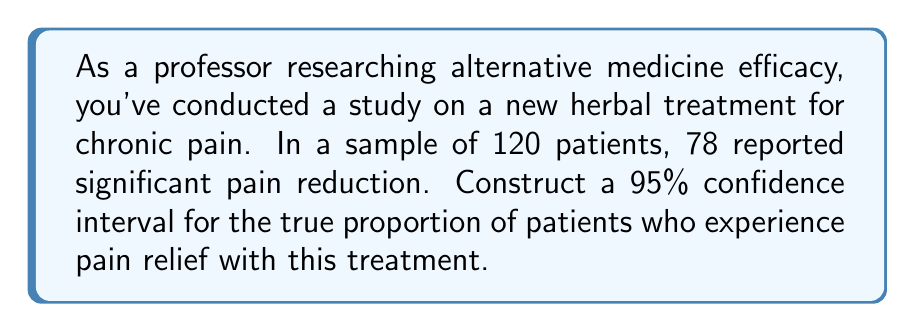Can you answer this question? Let's approach this step-by-step:

1) We're dealing with a proportion, so we'll use the formula for a confidence interval for a population proportion:

   $$\hat{p} \pm z^* \sqrt{\frac{\hat{p}(1-\hat{p})}{n}}$$

   Where:
   $\hat{p}$ = sample proportion
   $z^*$ = critical value for desired confidence level
   $n$ = sample size

2) Calculate $\hat{p}$:
   $$\hat{p} = \frac{78}{120} = 0.65$$

3) For a 95% confidence interval, $z^* = 1.96$

4) Now, let's plug these values into our formula:

   $$0.65 \pm 1.96 \sqrt{\frac{0.65(1-0.65)}{120}}$$

5) Simplify under the square root:
   $$0.65 \pm 1.96 \sqrt{\frac{0.65(0.35)}{120}}$$
   $$0.65 \pm 1.96 \sqrt{\frac{0.2275}{120}}$$
   $$0.65 \pm 1.96 \sqrt{0.001896}$$
   $$0.65 \pm 1.96(0.0435)$$

6) Multiply:
   $$0.65 \pm 0.0853$$

7) Calculate the interval:
   $$0.65 - 0.0853 = 0.5647$$
   $$0.65 + 0.0853 = 0.7353$$

Therefore, we are 95% confident that the true proportion of patients experiencing pain relief with this herbal treatment is between 0.5647 and 0.7353, or approximately 56.47% to 73.53%.
Answer: (0.5647, 0.7353) 